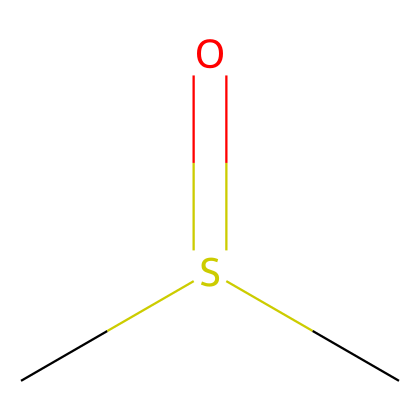What is the molecular formula of dimethyl sulfoxide? The chemical structure shows two carbon atoms (C), one sulfur atom (S), and one oxygen atom (O), which can be combined to form the molecular formula: C2H6OS.
Answer: C2H6OS How many oxygen atoms are present in dimethyl sulfoxide? From the SMILES representation, the "O" indicates there is one oxygen atom in the structure.
Answer: 1 What functional group is present in dimethyl sulfoxide? The presence of the "S(=O)" indicates that the compound contains a sulfoxide functional group, which is typical for compounds with sulfur and oxygen in this arrangement.
Answer: sulfoxide What type of compound is dimethyl sulfoxide classified as? Given that it contains carbon and sulfur, dimethyl sulfoxide is classified as an organosulfur compound.
Answer: organosulfur How many hydrogen atoms are in dimethyl sulfoxide? The SMILES structure implies there are six hydrogen atoms (indicated by the three terminal "C" sites that have hydrogen atoms bonded to them).
Answer: 6 What is the characteristic odor associated with dimethyl sulfoxide? DMSO is known for its garlic-like odor, which arises from its sulfur content.
Answer: garlic What is the primary use of dimethyl sulfoxide in sports? Dimethyl sulfoxide is primarily used in sports for its ability to penetrate the skin and deliver medications or relieve injuries effectively.
Answer: injury treatment 